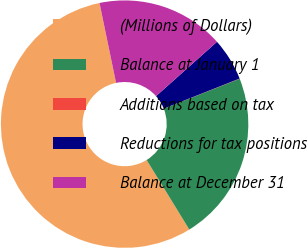Convert chart. <chart><loc_0><loc_0><loc_500><loc_500><pie_chart><fcel>(Millions of Dollars)<fcel>Balance at January 1<fcel>Additions based on tax<fcel>Reductions for tax positions<fcel>Balance at December 31<nl><fcel>55.51%<fcel>22.22%<fcel>0.03%<fcel>5.58%<fcel>16.67%<nl></chart> 